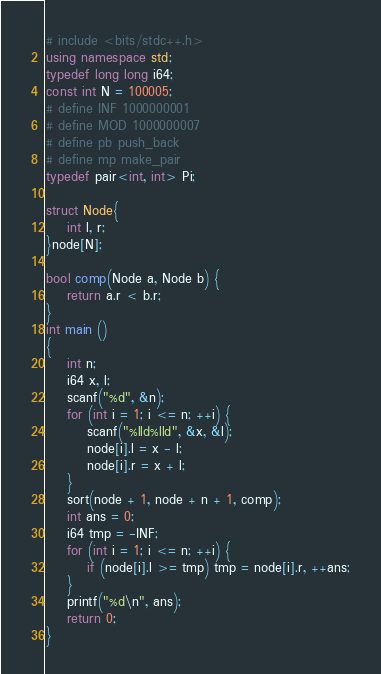<code> <loc_0><loc_0><loc_500><loc_500><_C++_># include <bits/stdc++.h>
using namespace std;
typedef long long i64;
const int N = 100005;
# define INF 1000000001
# define MOD 1000000007
# define pb push_back
# define mp make_pair
typedef pair<int, int> Pi;

struct Node{
    int l, r;
}node[N];

bool comp(Node a, Node b) {
    return a.r < b.r;
}
int main ()
{
    int n;
    i64 x, l;
    scanf("%d", &n);
    for (int i = 1; i <= n; ++i) {
        scanf("%lld%lld", &x, &l);
        node[i].l = x - l;
        node[i].r = x + l;
    }
    sort(node + 1, node + n + 1, comp);
    int ans = 0;
    i64 tmp = -INF;
    for (int i = 1; i <= n; ++i) {
        if (node[i].l >= tmp) tmp = node[i].r, ++ans;
    }
    printf("%d\n", ans);
    return 0;
}
</code> 